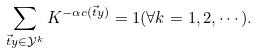Convert formula to latex. <formula><loc_0><loc_0><loc_500><loc_500>\sum _ { \vec { t } { y } \in \mathcal { Y } ^ { k } } K ^ { - \alpha c ( \vec { t } { y } ) } = 1 ( \forall k = 1 , 2 , \cdots ) .</formula> 